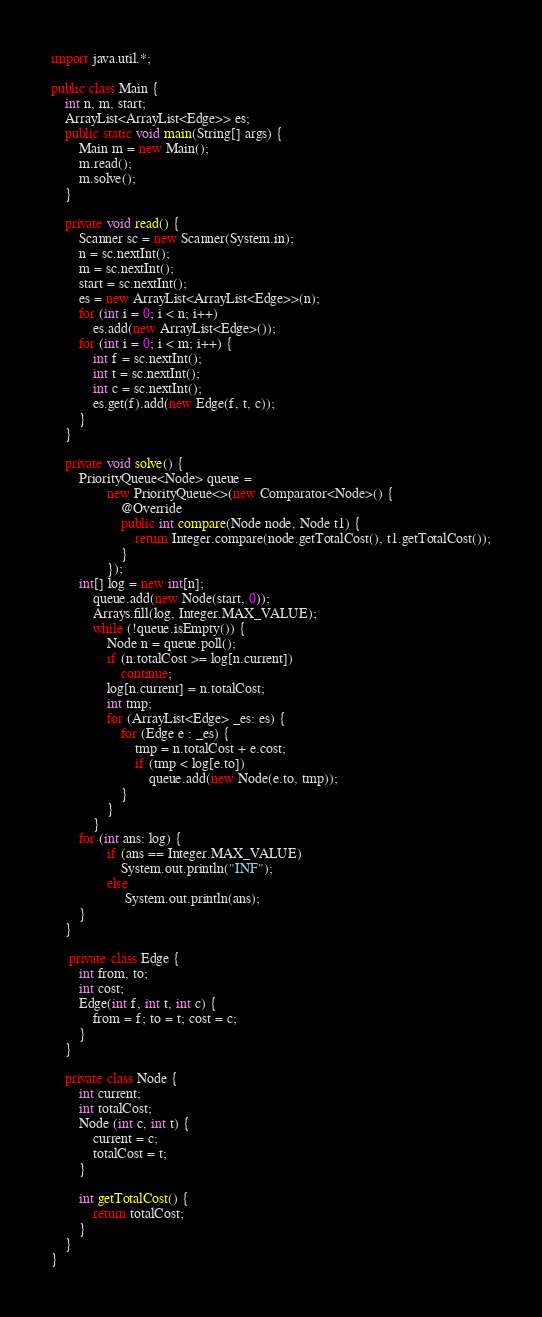Convert code to text. <code><loc_0><loc_0><loc_500><loc_500><_Java_>
import java.util.*;

public class Main {
    int n, m, start;
    ArrayList<ArrayList<Edge>> es;
    public static void main(String[] args) {
        Main m = new Main();
        m.read();
        m.solve();
    }

    private void read() {
        Scanner sc = new Scanner(System.in);
        n = sc.nextInt();
        m = sc.nextInt();
        start = sc.nextInt();
        es = new ArrayList<ArrayList<Edge>>(n);
        for (int i = 0; i < n; i++)
            es.add(new ArrayList<Edge>());
        for (int i = 0; i < m; i++) {
            int f = sc.nextInt();
            int t = sc.nextInt();
            int c = sc.nextInt();
            es.get(f).add(new Edge(f, t, c));
        }
    }

    private void solve() {
        PriorityQueue<Node> queue =
                new PriorityQueue<>(new Comparator<Node>() {
                    @Override
                    public int compare(Node node, Node t1) {
                        return Integer.compare(node.getTotalCost(), t1.getTotalCost());
                    }
                });
        int[] log = new int[n];
            queue.add(new Node(start, 0));
            Arrays.fill(log, Integer.MAX_VALUE);
            while (!queue.isEmpty()) {
                Node n = queue.poll();
                if (n.totalCost >= log[n.current])
                    continue;
                log[n.current] = n.totalCost;
                int tmp;
                for (ArrayList<Edge> _es: es) {
                    for (Edge e : _es) {
                        tmp = n.totalCost + e.cost;
                        if (tmp < log[e.to])
                            queue.add(new Node(e.to, tmp));
                    }
                }
            }
        for (int ans: log) {
                if (ans == Integer.MAX_VALUE)
                    System.out.println("INF");
                else
                     System.out.println(ans);
        }
    }

     private class Edge {
        int from, to;
        int cost;
        Edge(int f, int t, int c) {
            from = f; to = t; cost = c;
        }
    }

    private class Node {
        int current;
        int totalCost;
        Node (int c, int t) {
            current = c;
            totalCost = t;
        }

        int getTotalCost() {
            return totalCost;
        }
    }
}</code> 